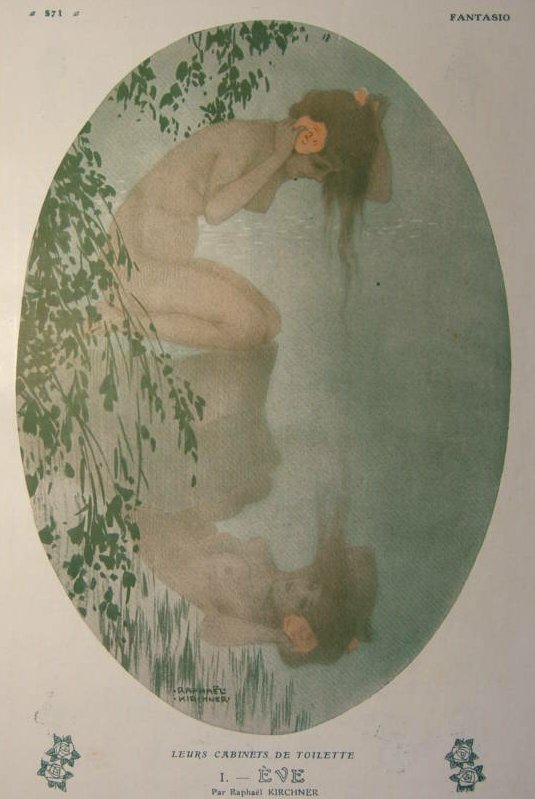Write a poem inspired by this image. In a world where whispers paint the dawn,
A nymph rests by the water's gentle yawn.
Her thoughts, a stream of silent grace,
In nature's hold, she finds her place.
A flower bright against her cheek,
Words of love it seems to speak.
In emerald hues and fragile light,
She holds the calm of endless nights.
Reflections of a tranquil heart,
Where earth and spirit form no part.
Here, in stillness, time unfurls,
A moment's peace within this world. 